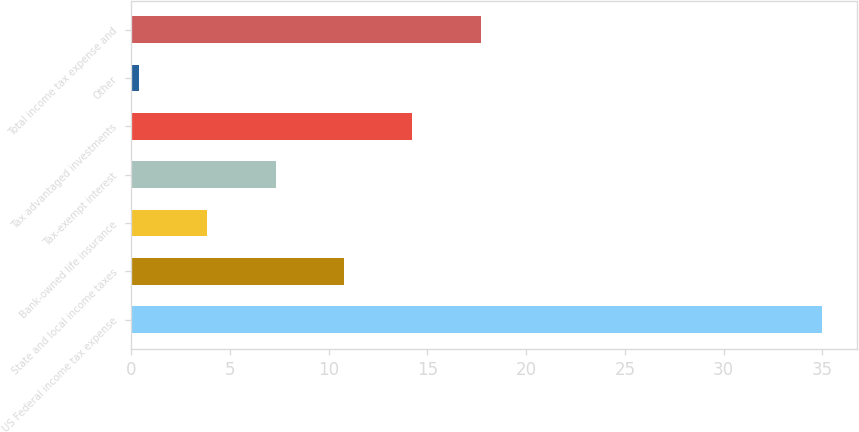Convert chart. <chart><loc_0><loc_0><loc_500><loc_500><bar_chart><fcel>US Federal income tax expense<fcel>State and local income taxes<fcel>Bank-owned life insurance<fcel>Tax-exempt interest<fcel>Tax advantaged investments<fcel>Other<fcel>Total income tax expense and<nl><fcel>35<fcel>10.78<fcel>3.86<fcel>7.32<fcel>14.24<fcel>0.4<fcel>17.7<nl></chart> 